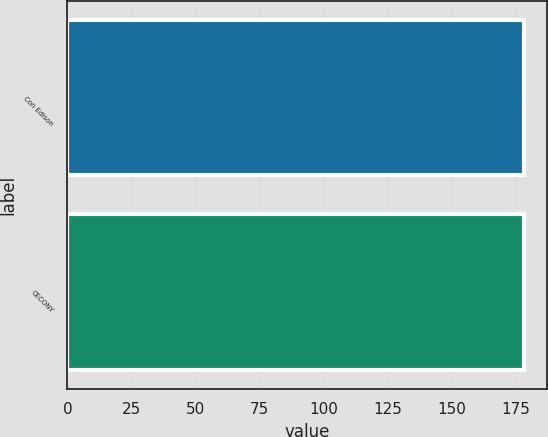Convert chart to OTSL. <chart><loc_0><loc_0><loc_500><loc_500><bar_chart><fcel>Con Edison<fcel>CECONY<nl><fcel>178<fcel>178.1<nl></chart> 